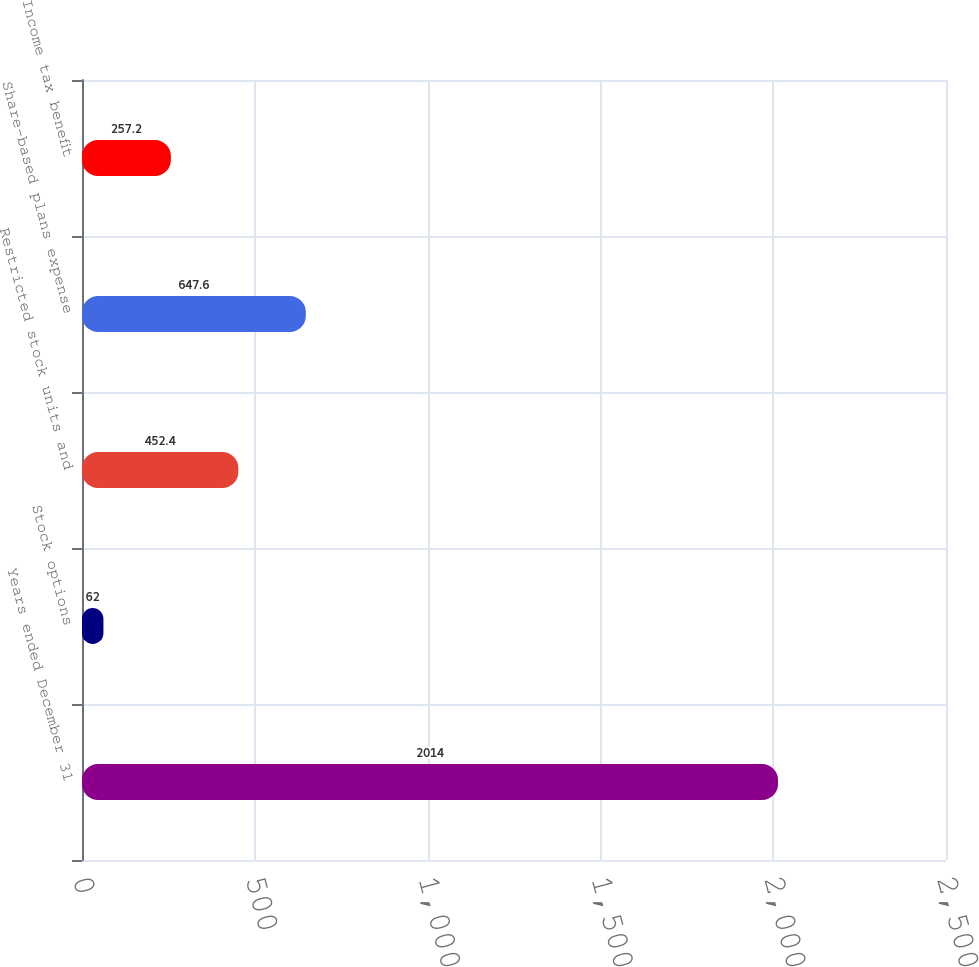<chart> <loc_0><loc_0><loc_500><loc_500><bar_chart><fcel>Years ended December 31<fcel>Stock options<fcel>Restricted stock units and<fcel>Share-based plans expense<fcel>Income tax benefit<nl><fcel>2014<fcel>62<fcel>452.4<fcel>647.6<fcel>257.2<nl></chart> 